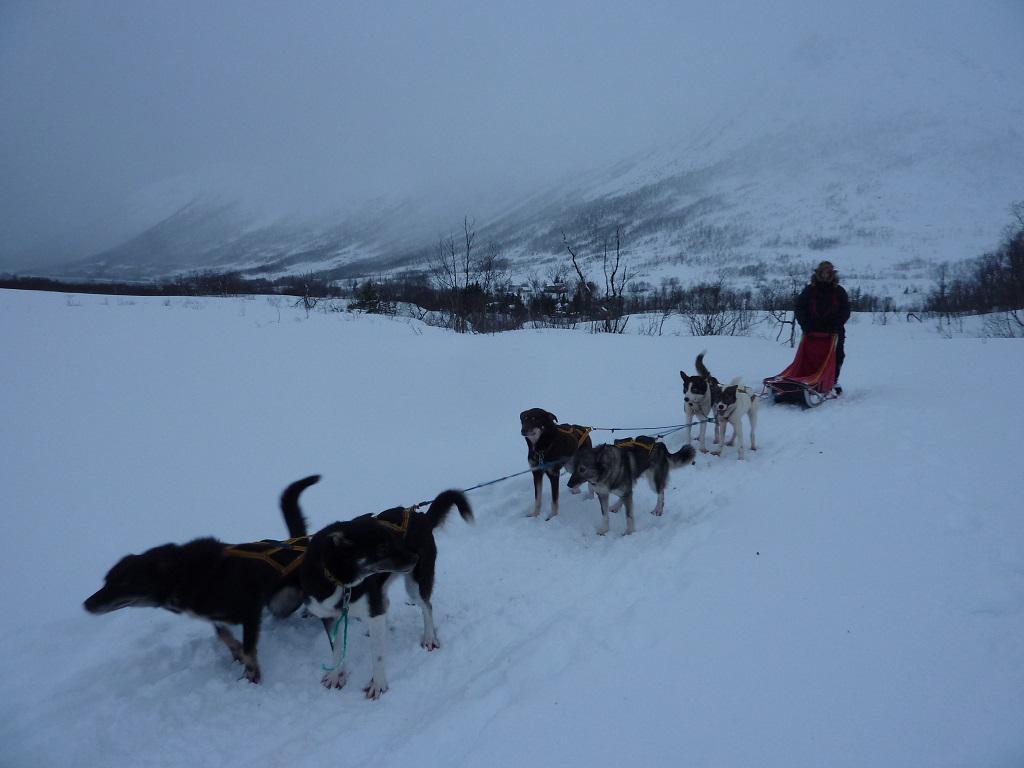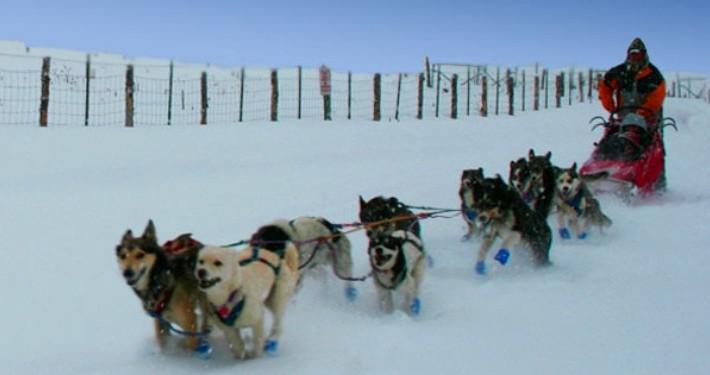The first image is the image on the left, the second image is the image on the right. Given the left and right images, does the statement "The dog sled teams in the left and right images move forward at some angle and appear to be heading toward each other." hold true? Answer yes or no. No. The first image is the image on the left, the second image is the image on the right. Given the left and right images, does the statement "The dogs in the left image are heading to the right." hold true? Answer yes or no. No. 